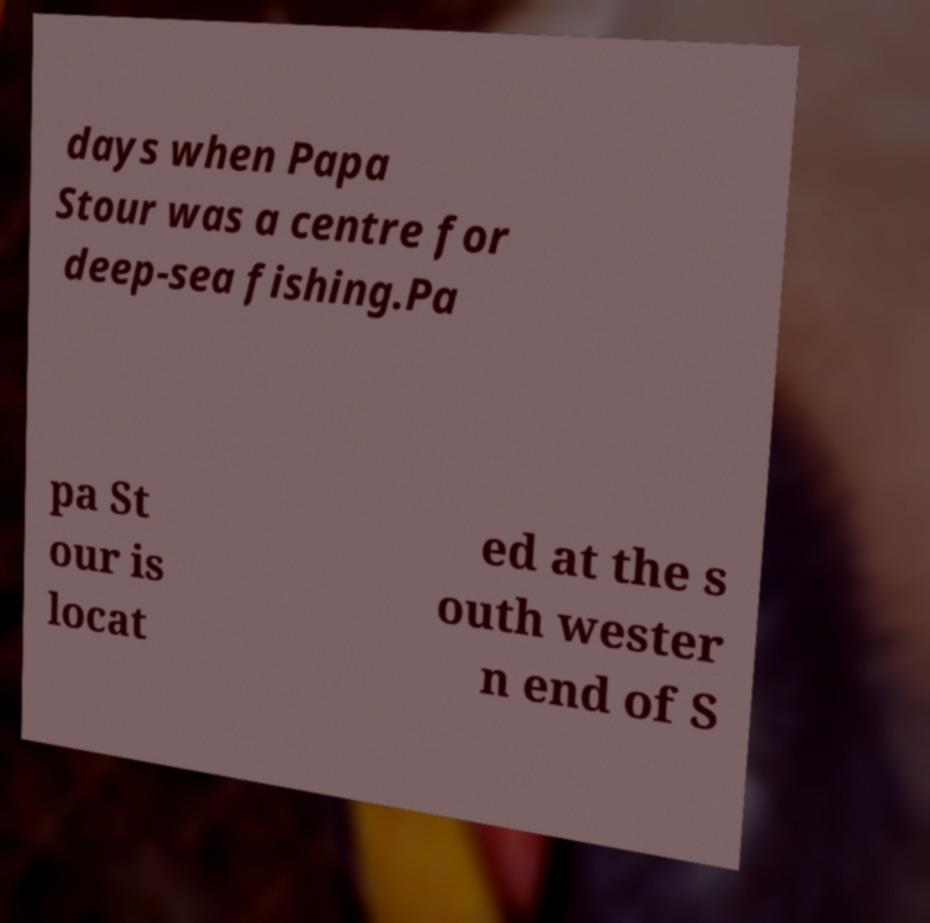Can you accurately transcribe the text from the provided image for me? days when Papa Stour was a centre for deep-sea fishing.Pa pa St our is locat ed at the s outh wester n end of S 